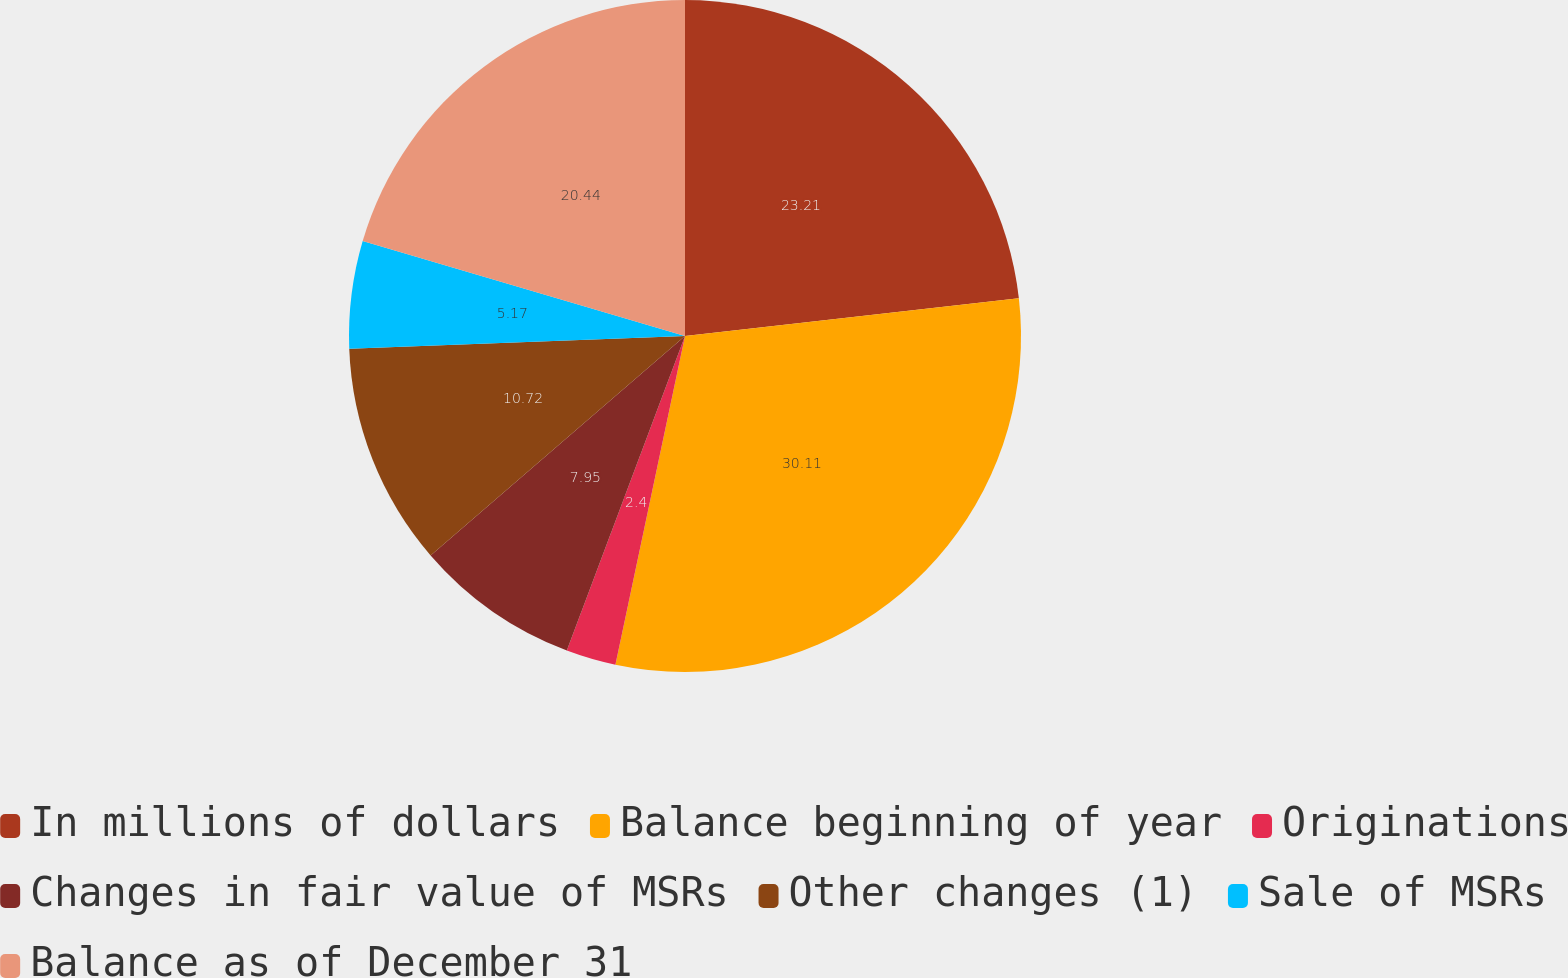Convert chart to OTSL. <chart><loc_0><loc_0><loc_500><loc_500><pie_chart><fcel>In millions of dollars<fcel>Balance beginning of year<fcel>Originations<fcel>Changes in fair value of MSRs<fcel>Other changes (1)<fcel>Sale of MSRs<fcel>Balance as of December 31<nl><fcel>23.21%<fcel>30.11%<fcel>2.4%<fcel>7.95%<fcel>10.72%<fcel>5.17%<fcel>20.44%<nl></chart> 